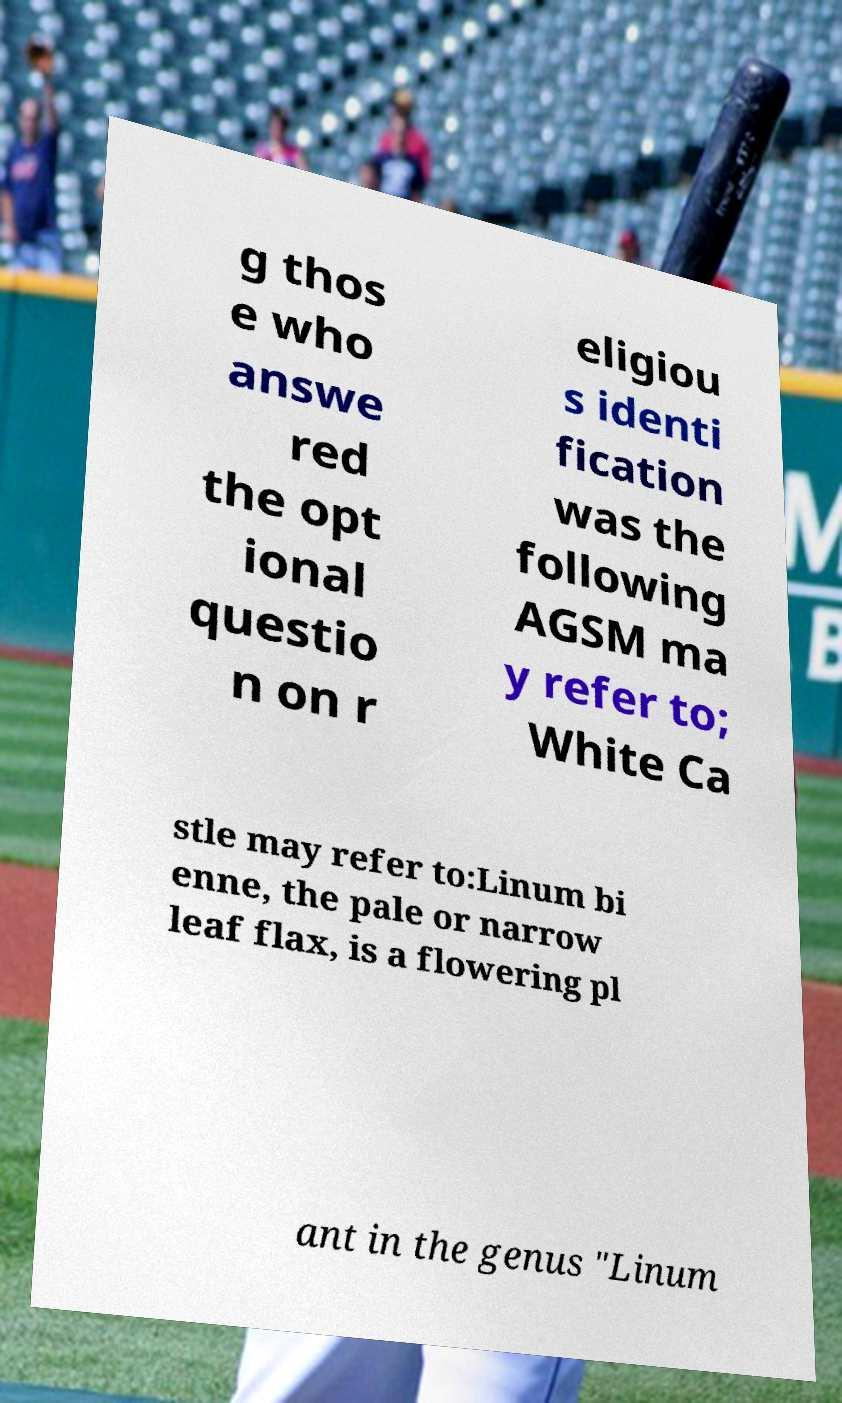There's text embedded in this image that I need extracted. Can you transcribe it verbatim? g thos e who answe red the opt ional questio n on r eligiou s identi fication was the following AGSM ma y refer to; White Ca stle may refer to:Linum bi enne, the pale or narrow leaf flax, is a flowering pl ant in the genus "Linum 